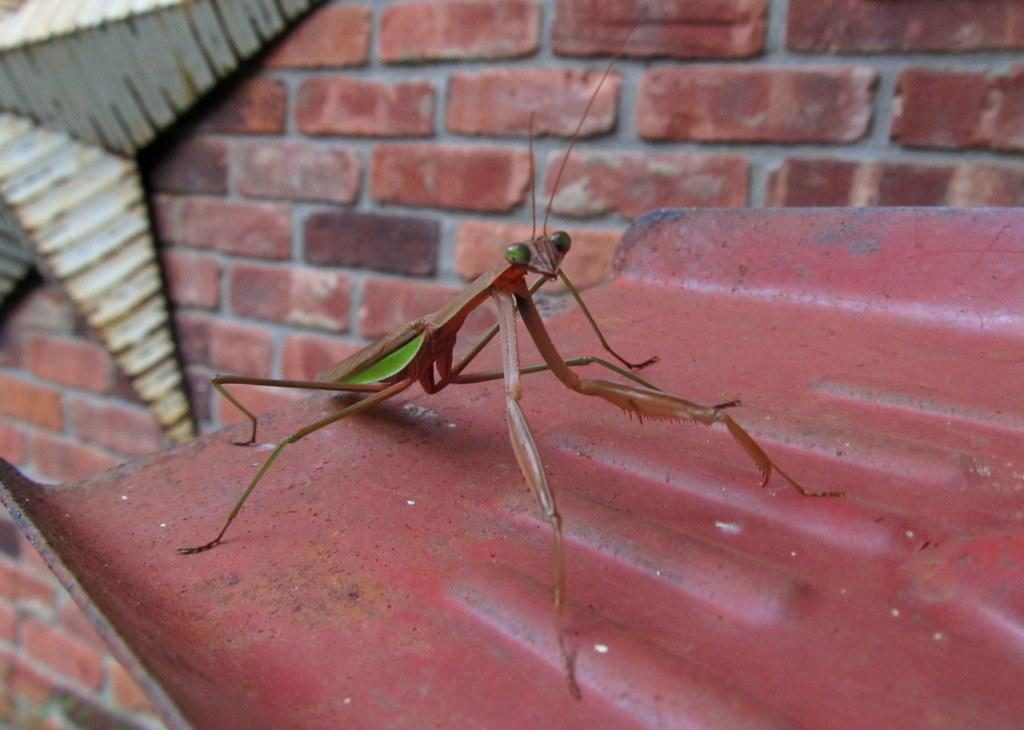What type of insect can be seen in the image? There is a mantis in the image. What is the mantis resting on? The mantis is on an iron plate. Can you describe any decorative elements in the image? There is a star attached to the wall in the image. What material is the wall made of? The wall is built with bricks. Where is the nest of the mantis located in the image? There is no nest present in the image, as mantises do not build nests. 